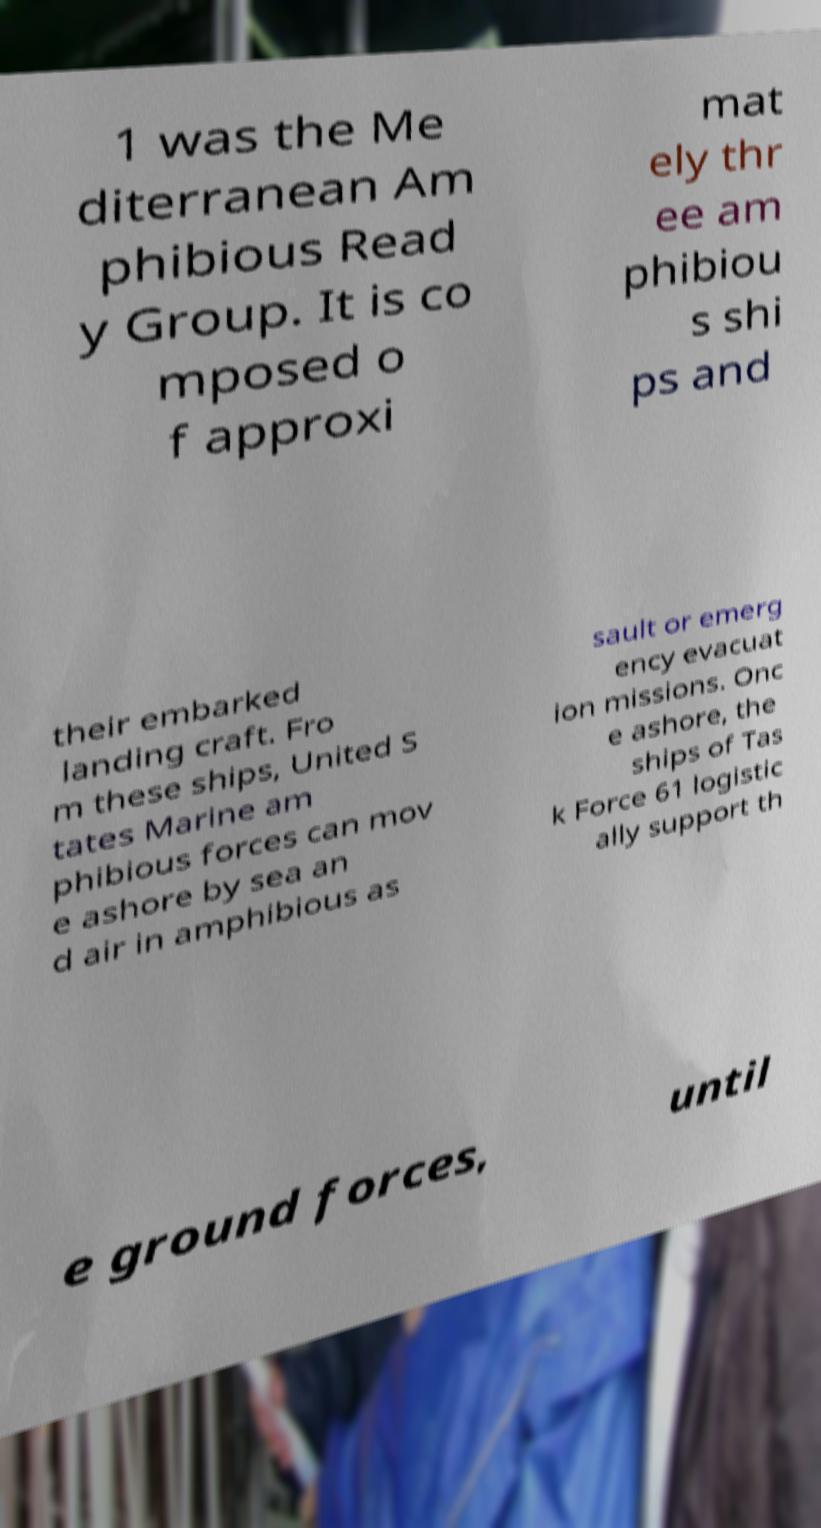What messages or text are displayed in this image? I need them in a readable, typed format. 1 was the Me diterranean Am phibious Read y Group. It is co mposed o f approxi mat ely thr ee am phibiou s shi ps and their embarked landing craft. Fro m these ships, United S tates Marine am phibious forces can mov e ashore by sea an d air in amphibious as sault or emerg ency evacuat ion missions. Onc e ashore, the ships of Tas k Force 61 logistic ally support th e ground forces, until 